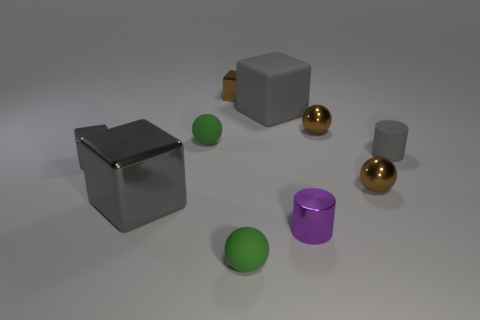There is a small sphere in front of the large block left of the tiny green matte thing in front of the purple object; what is its color?
Provide a succinct answer. Green. There is a green rubber object behind the small gray cube; does it have the same shape as the green matte object that is in front of the big shiny thing?
Offer a terse response. Yes. What number of rubber cylinders are there?
Offer a terse response. 1. There is another cylinder that is the same size as the metal cylinder; what is its color?
Keep it short and to the point. Gray. Is the material of the small brown object that is left of the small purple cylinder the same as the brown sphere that is in front of the gray matte cylinder?
Your answer should be very brief. Yes. There is a brown object that is to the right of the tiny brown ball that is behind the tiny rubber cylinder; what size is it?
Keep it short and to the point. Small. There is a small object that is behind the large gray rubber thing; what is it made of?
Your response must be concise. Metal. What number of objects are green rubber spheres in front of the large metal block or metal blocks on the left side of the brown metal block?
Keep it short and to the point. 3. There is a gray thing that is the same shape as the purple object; what material is it?
Offer a terse response. Rubber. There is a tiny block in front of the large matte object; does it have the same color as the tiny rubber cylinder that is on the right side of the big gray metal cube?
Your answer should be compact. Yes. 